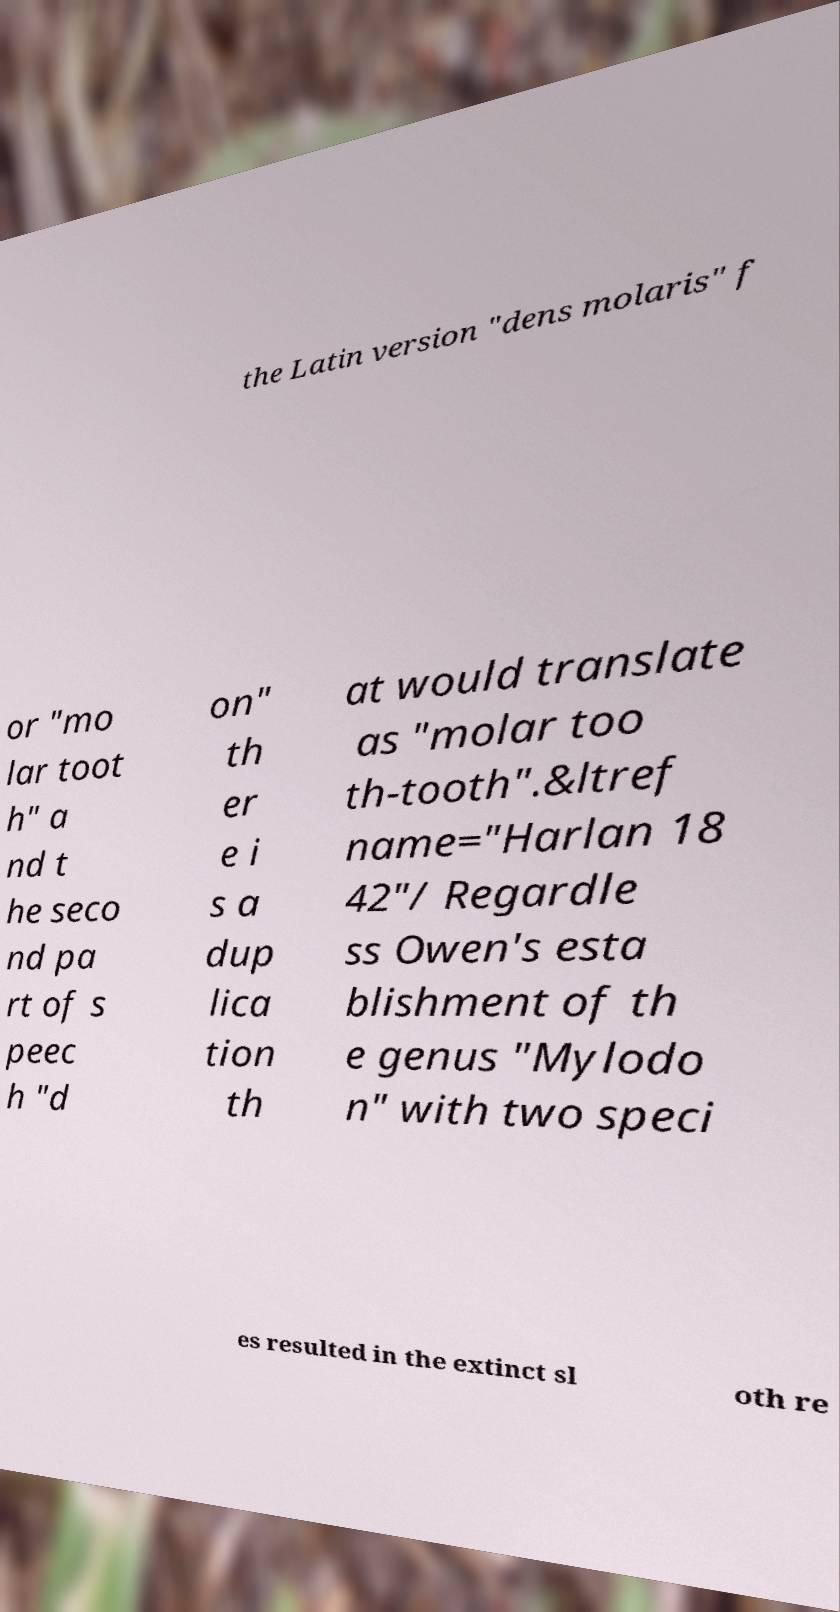Can you accurately transcribe the text from the provided image for me? the Latin version "dens molaris" f or "mo lar toot h" a nd t he seco nd pa rt of s peec h "d on" th er e i s a dup lica tion th at would translate as "molar too th-tooth".&ltref name="Harlan 18 42"/ Regardle ss Owen's esta blishment of th e genus "Mylodo n" with two speci es resulted in the extinct sl oth re 